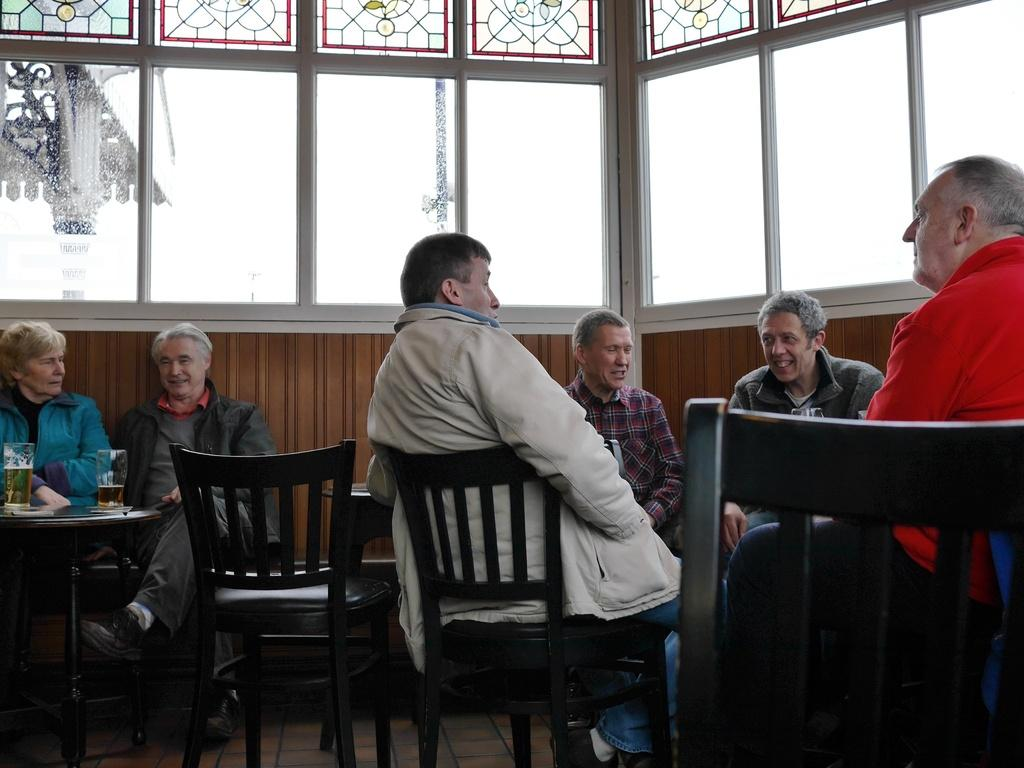What are the people in the image doing? The people in the image are sitting on chairs. What is present in the image besides the people? There is a table in the image. What is on the table? The table has tumblers of alcohol on it. What can be seen through the windows in the image? A pillar is visible through one of the windows. What type of cake is being served to the people in the image? There is no cake present in the image; the table has tumblers of alcohol on it. How many people are sleeping in the image? There are no people sleeping in the image; the people are sitting on chairs. 